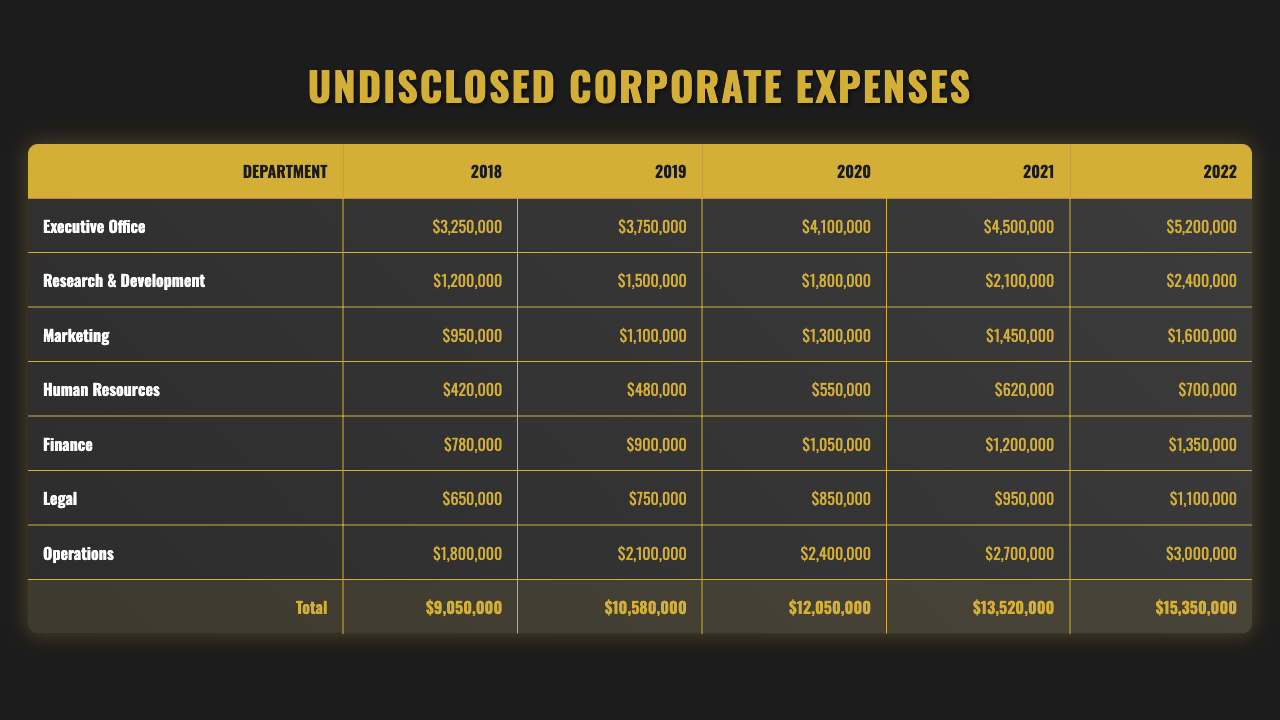What department had the highest undisclosed expenses in 2022? In the table, I can see that the Executive Office had $5,200,000 in expenses in 2022, which is higher than any other department's expenses for that year.
Answer: Executive Office What was the total undisclosed expense for Marketing from 2018 to 2022? Looking at the expenses for Marketing across the years, I add the values: $950,000 + $1,100,000 + $1,300,000 + $1,450,000 + $1,600,000 = $6,400,000.
Answer: $6,400,000 Did the Human Resources department have increasing expenses every year? By reviewing the expenses per year for Human Resources, I see they are $420,000, $480,000, $550,000, $620,000, and $700,000 respectively, which are all increasing values.
Answer: Yes What was the percentage increase in expenses for Finance from 2018 to 2022? I first find the 2018 expense of Finance ($780,000) and the 2022 expense ($1,350,000). I then calculate the percentage increase: ((1,350,000 - 780,000) / 780,000) * 100 = 73.08%.
Answer: 73.08% Which department had the lowest undisclosed expenses in 2020? By checking the values for each department in 2020, I see that Human Resources had the lowest expense of $550,000.
Answer: Human Resources What was the average undisclosed expense for the Operations department over all years? The Operations expenses for the years are $1,800,000, $2,100,000, $2,400,000, $2,700,000, and $3,000,000. I first calculate the sum, which is $11,000,000. Then, I divide by 5 (the number of years) to get an average of $2,200,000.
Answer: $2,200,000 Is it true that the Research & Development department's expenses doubled over the five years? I evaluate the 2018 expense of $1,200,000 and the 2022 expense of $2,400,000. Since $2,400,000 is exactly double $1,200,000, the statement is true.
Answer: Yes What is the total undisclosed expense across all departments in 2021? I sum the expenses for each department for the year 2021: $4,500,000 (Executive Office) + $2,100,000 (R&D) + $1,450,000 (Marketing) + $620,000 (HR) + $1,200,000 (Finance) + $950,000 (Legal) + $2,700,000 (Operations) = $13,620,000.
Answer: $13,620,000 Which year had the highest total undisclosed expenses and what was the amount? I need to compare the total expenses for each year: 2018 = $8,350,000, 2019 = $9,300,000, 2020 = $10,550,000, 2021 = $12,620,000, and 2022 = $14,750,000. The highest total is 2022 at $14,750,000.
Answer: 2022, $14,750,000 Was there any department that spent less than $1 million in 2018? After examining the 2018 expenses, I find that only Human Resources ($420,000), Marketing ($950,000), and Finance ($780,000) spent less than $1 million.
Answer: Yes What was the total undisclosed expense for the Legal department over the five years? I add up the Legal department's expenses for each year: $650,000 + $750,000 + $850,000 + $950,000 + $1,100,000 = $3,400,000.
Answer: $3,400,000 